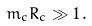Convert formula to latex. <formula><loc_0><loc_0><loc_500><loc_500>m _ { c } R _ { c } \gg 1 \, .</formula> 